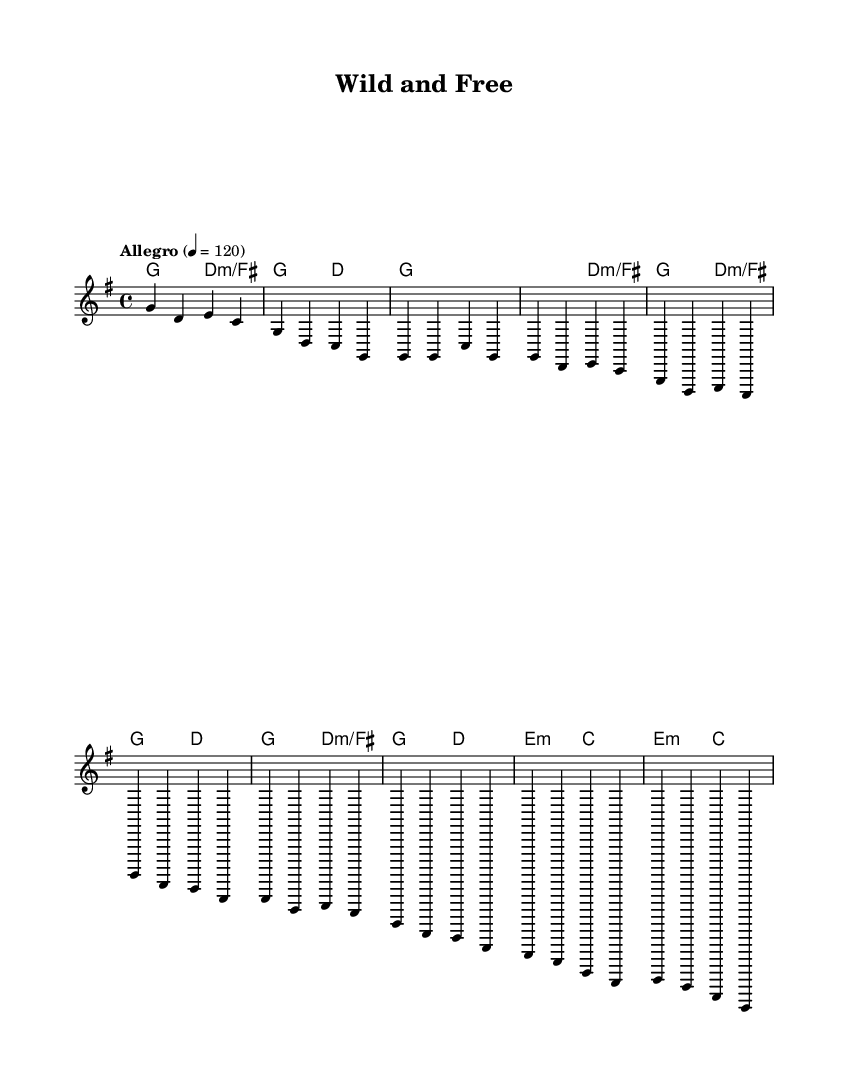What is the key signature of this music? The key signature is G major, which has one sharp (F#).
Answer: G major What is the time signature of this music? The time signature is 4/4, indicating four beats per measure.
Answer: 4/4 What is the tempo marking of this piece? The tempo marking is "Allegro," which generally indicates a fast tempo.
Answer: Allegro How many measures are in the chorus section? The chorus section contains four measures, each repeated twice in the provided score.
Answer: Four Identify the chord in the bridge. The chord in the bridge is E minor, indicated by "e2:m".
Answer: E minor What is the melody's starting note? The melody starts on the note G, which is the first note in the introductory measures.
Answer: G What theme is emphasized in the lyrics of this piece? The theme emphasized is individuality and self-expression, as indicated by the title and style of the song.
Answer: Individuality 